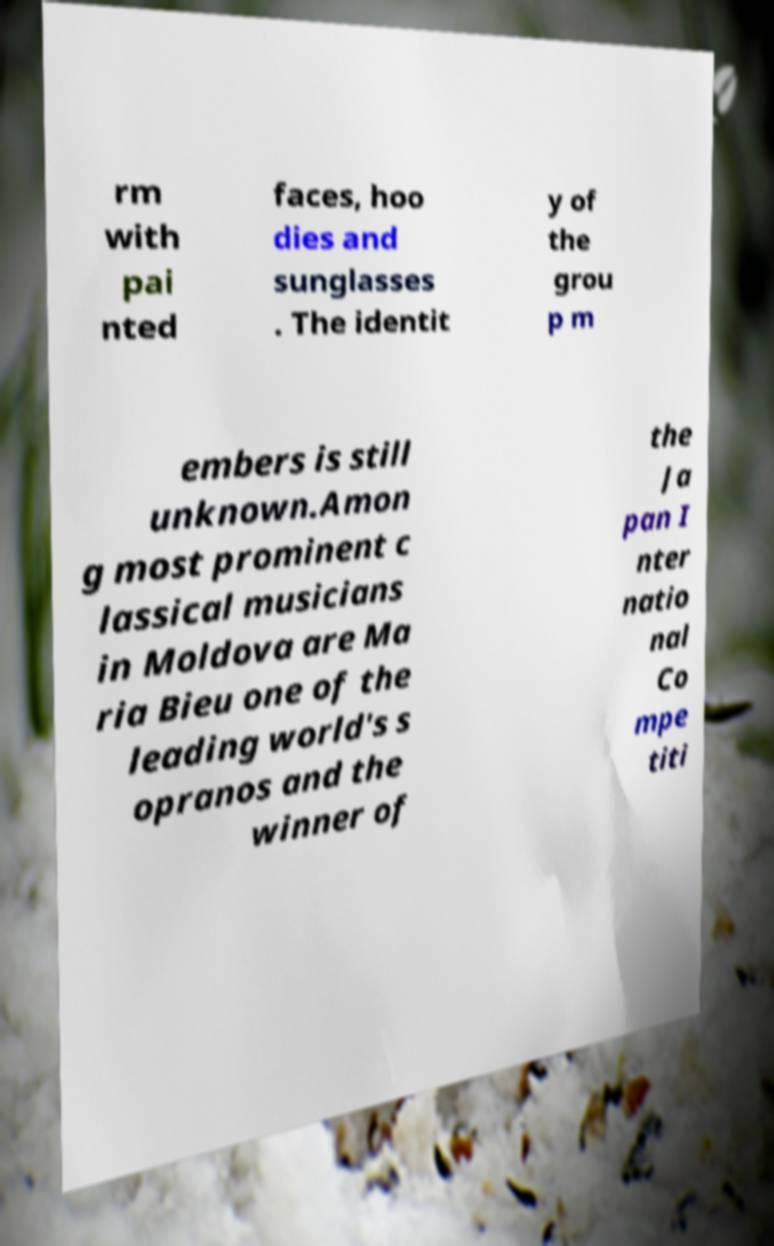Could you assist in decoding the text presented in this image and type it out clearly? rm with pai nted faces, hoo dies and sunglasses . The identit y of the grou p m embers is still unknown.Amon g most prominent c lassical musicians in Moldova are Ma ria Bieu one of the leading world's s opranos and the winner of the Ja pan I nter natio nal Co mpe titi 